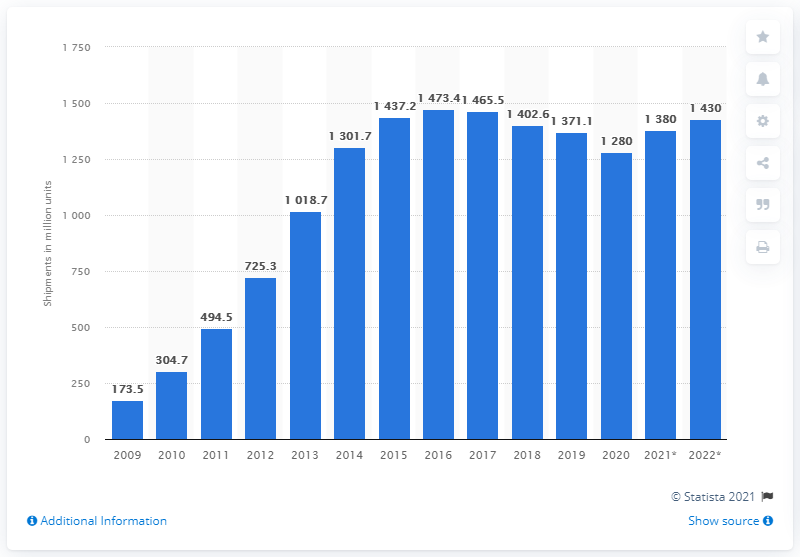Specify some key components in this picture. The total unit shipments of smartphones from 2009 to 2016 were approximately 1465.5 units. In 2020, it is estimated that 12,800 smartphones were shipped. 